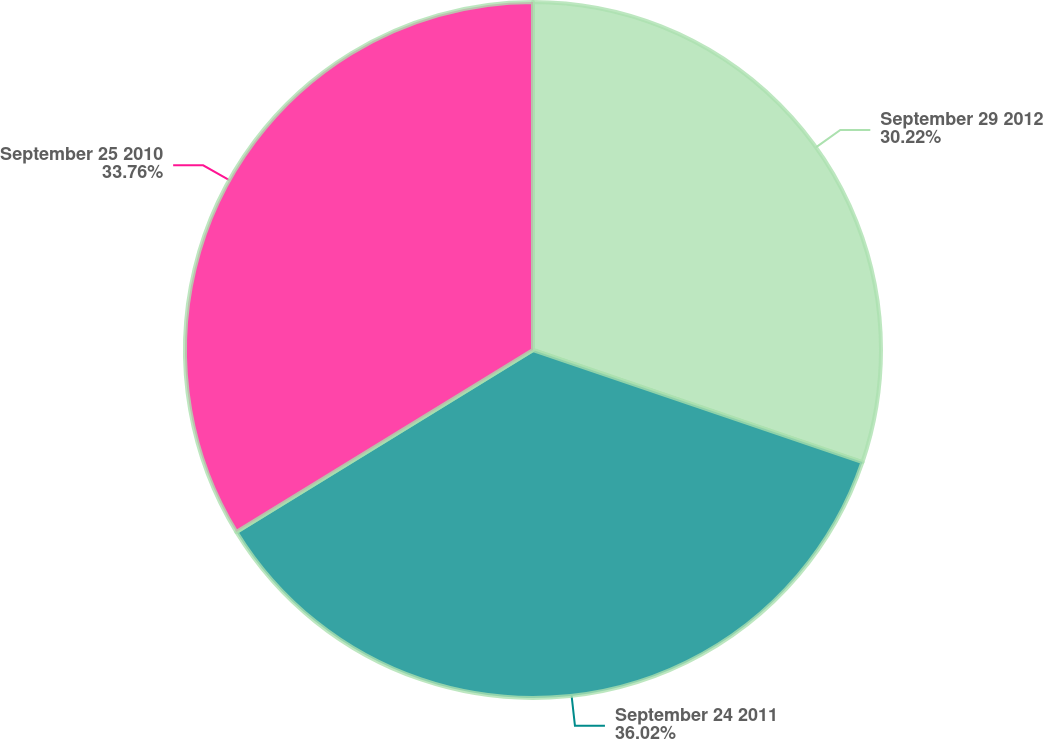Convert chart. <chart><loc_0><loc_0><loc_500><loc_500><pie_chart><fcel>September 29 2012<fcel>September 24 2011<fcel>September 25 2010<nl><fcel>30.22%<fcel>36.03%<fcel>33.76%<nl></chart> 